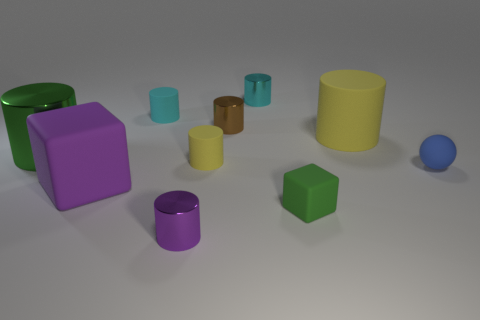Subtract all brown cylinders. How many cylinders are left? 6 Subtract all purple shiny cylinders. How many cylinders are left? 6 Subtract all gray cylinders. Subtract all brown cubes. How many cylinders are left? 7 Subtract all blocks. How many objects are left? 8 Subtract all blue things. Subtract all tiny cyan rubber spheres. How many objects are left? 9 Add 5 large yellow rubber things. How many large yellow rubber things are left? 6 Add 1 big cyan shiny cylinders. How many big cyan shiny cylinders exist? 1 Subtract 1 green cubes. How many objects are left? 9 